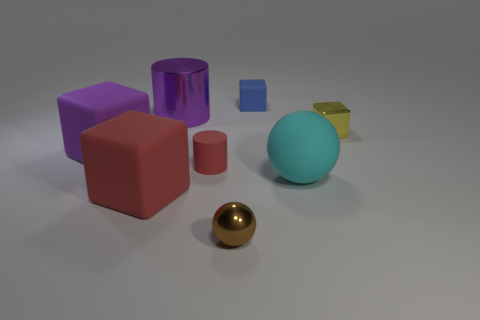Does the big purple rubber thing have the same shape as the shiny object that is on the right side of the blue block?
Make the answer very short. Yes. How many spheres are small yellow metal objects or purple metallic things?
Provide a succinct answer. 0. What shape is the small rubber thing to the left of the shiny sphere?
Your answer should be compact. Cylinder. What number of cylinders are the same material as the big sphere?
Make the answer very short. 1. Is the number of small rubber cylinders on the left side of the large matte ball less than the number of small blue objects?
Offer a terse response. No. What is the size of the rubber block behind the large rubber thing behind the red rubber cylinder?
Give a very brief answer. Small. There is a small cylinder; is its color the same as the large block that is in front of the matte cylinder?
Offer a very short reply. Yes. What material is the other cube that is the same size as the yellow cube?
Offer a terse response. Rubber. Are there fewer large rubber cubes in front of the cyan matte sphere than big matte things on the left side of the metal cylinder?
Your answer should be very brief. Yes. There is a metallic object that is to the right of the sphere in front of the large cyan matte sphere; what shape is it?
Provide a short and direct response. Cube. 